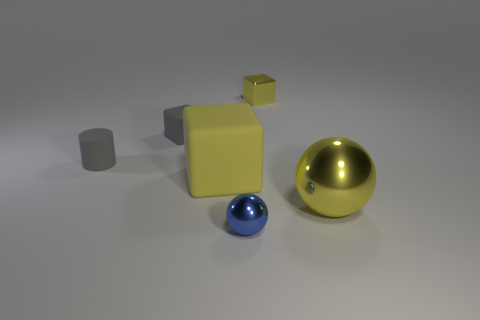Add 3 small metal blocks. How many objects exist? 9 Subtract all balls. How many objects are left? 4 Subtract all tiny yellow shiny blocks. Subtract all large yellow cubes. How many objects are left? 4 Add 4 yellow metal things. How many yellow metal things are left? 6 Add 6 large yellow shiny things. How many large yellow shiny things exist? 7 Subtract 0 cyan cylinders. How many objects are left? 6 